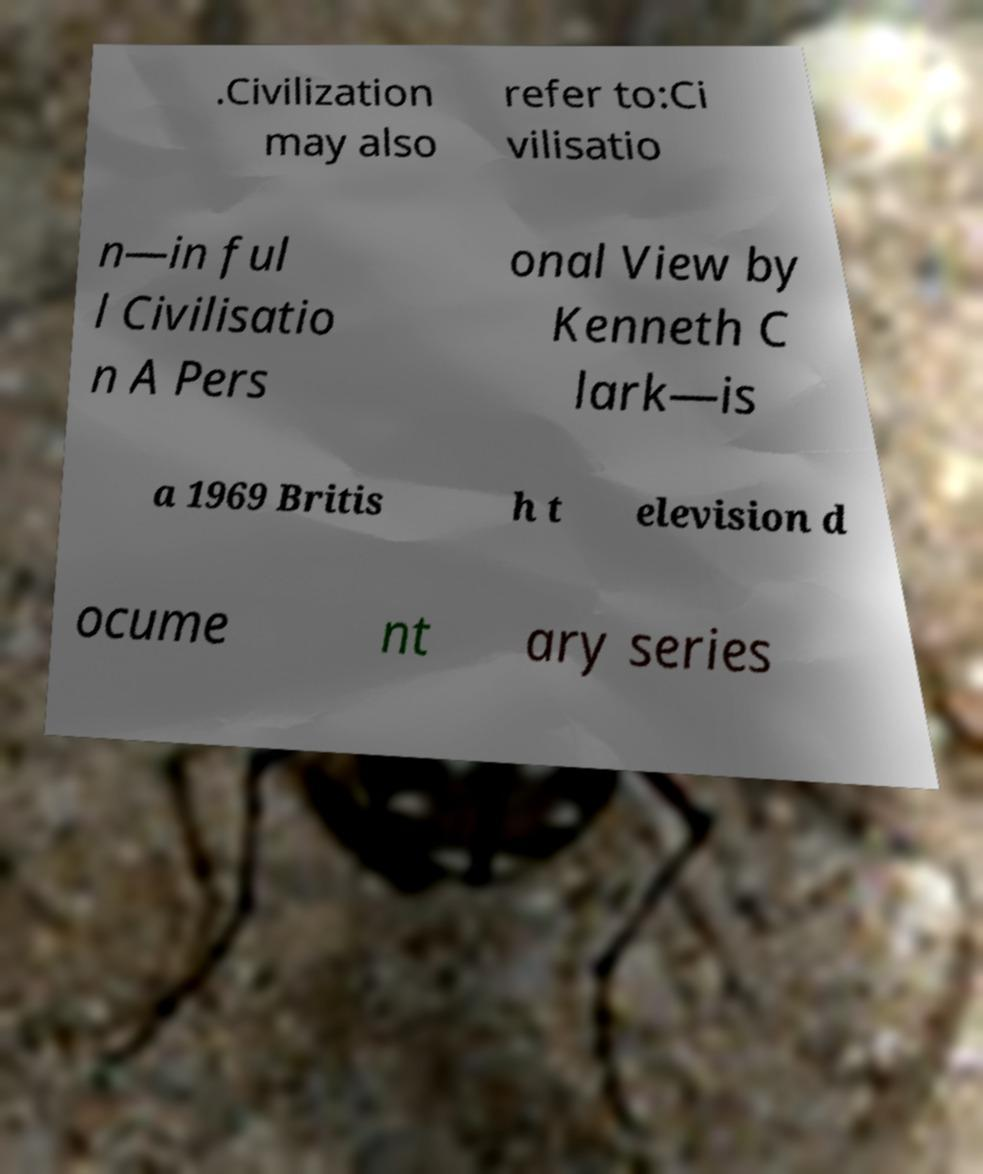Please read and relay the text visible in this image. What does it say? .Civilization may also refer to:Ci vilisatio n—in ful l Civilisatio n A Pers onal View by Kenneth C lark—is a 1969 Britis h t elevision d ocume nt ary series 